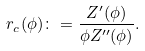<formula> <loc_0><loc_0><loc_500><loc_500>r _ { c } ( \phi ) \colon = \frac { Z ^ { \prime } ( \phi ) } { \phi Z ^ { \prime \prime } ( \phi ) } .</formula> 